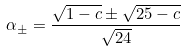Convert formula to latex. <formula><loc_0><loc_0><loc_500><loc_500>\alpha _ { \pm } = \frac { \sqrt { 1 - c } \pm \sqrt { 2 5 - c } } { \sqrt { 2 4 } }</formula> 